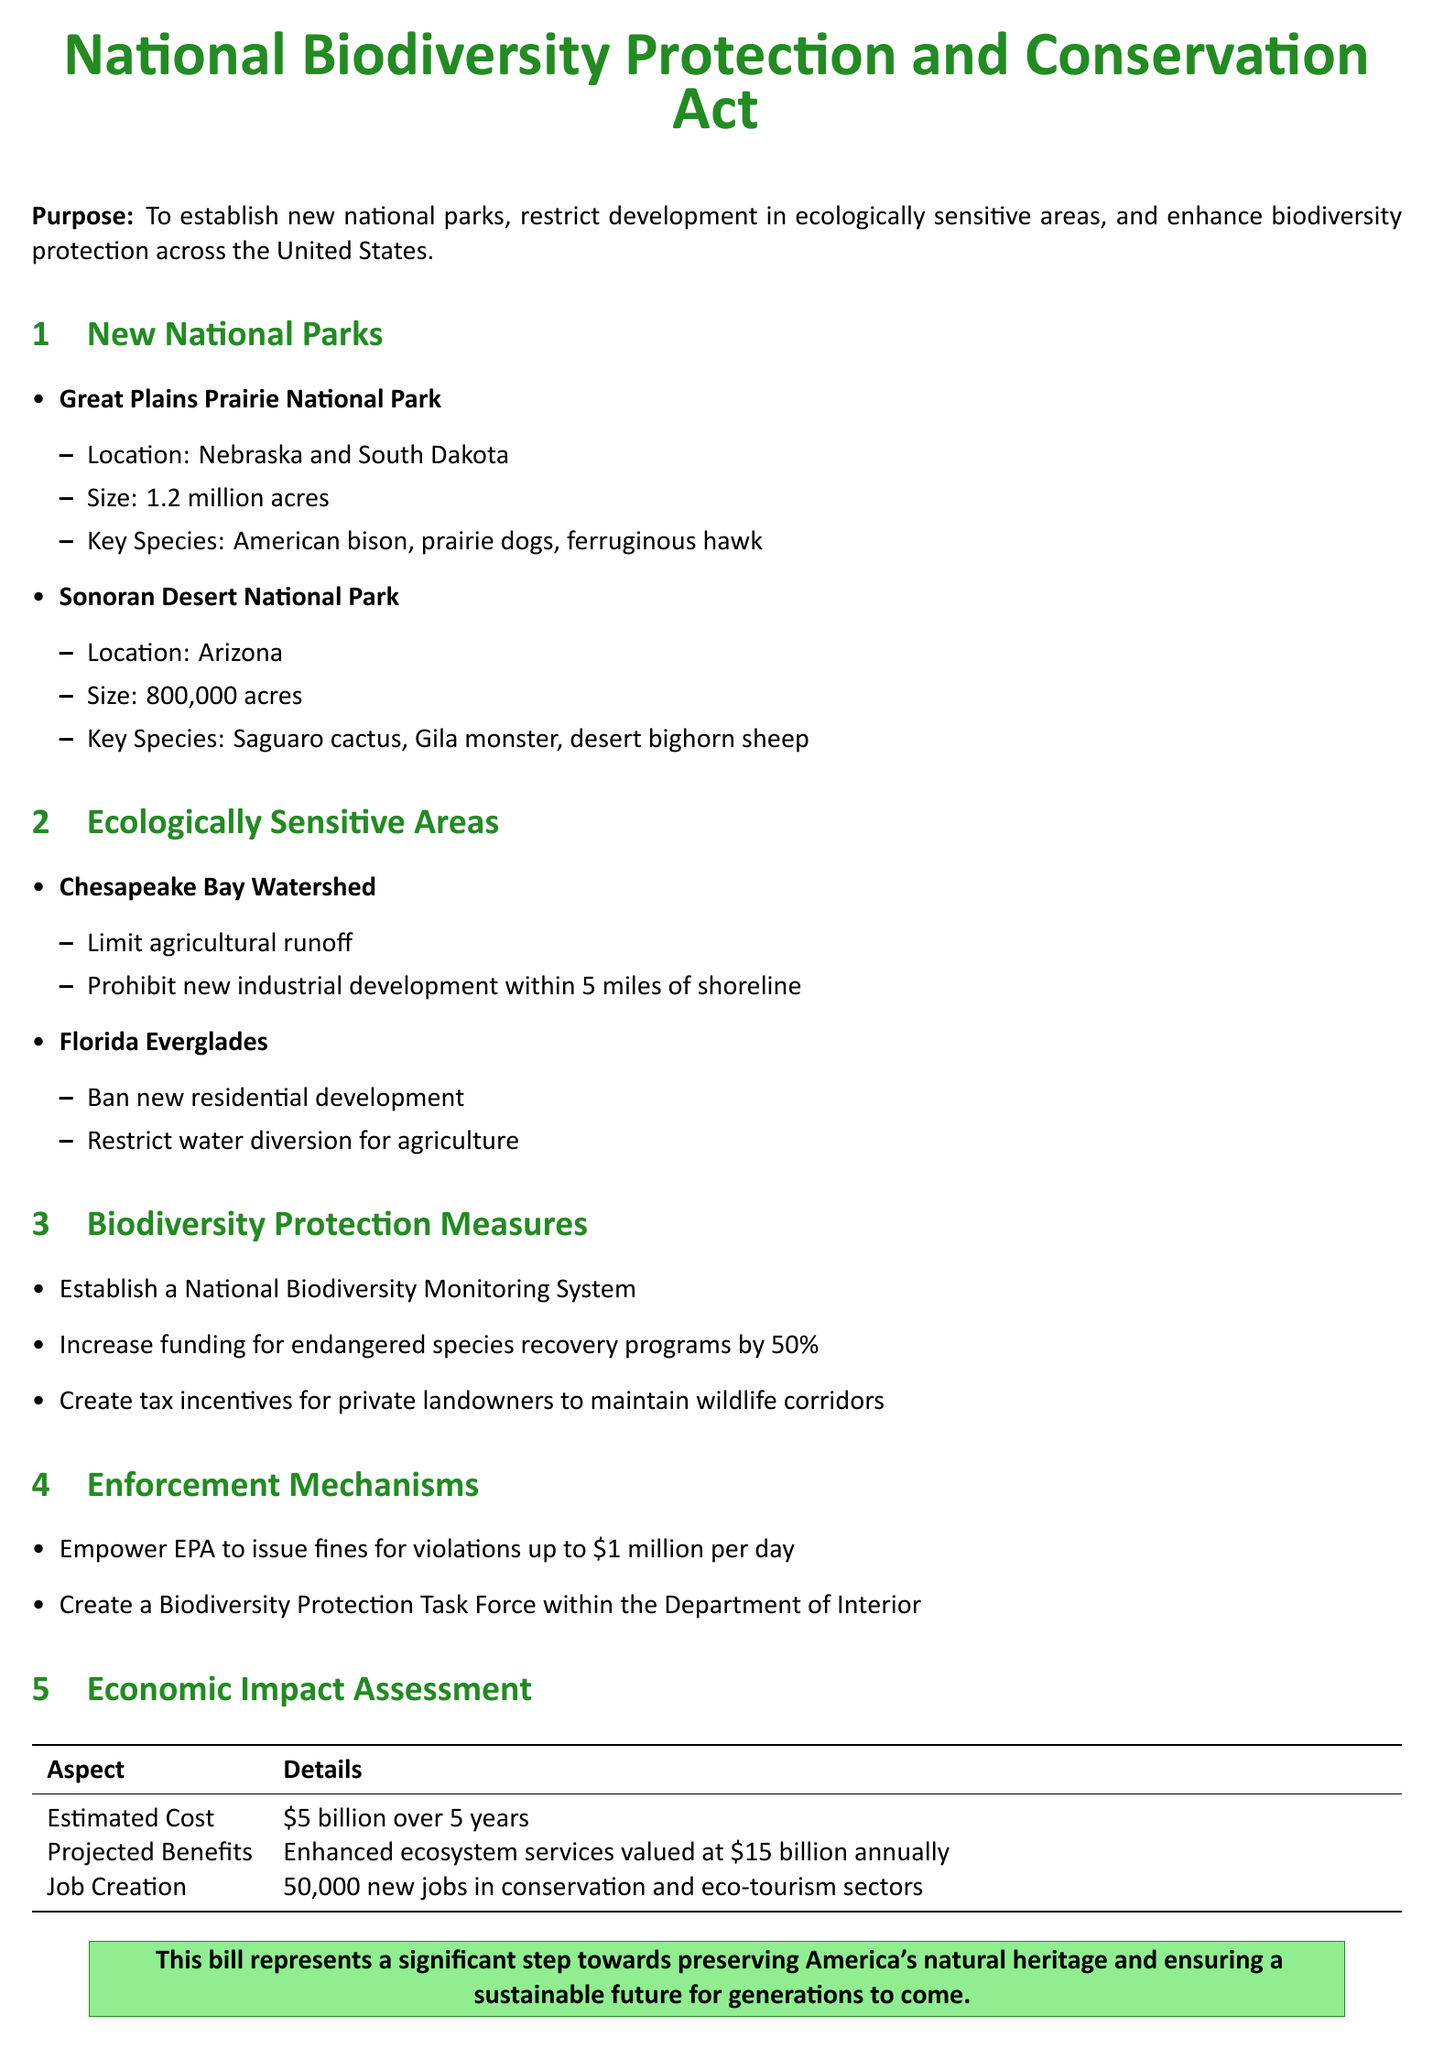What is the purpose of the bill? The purpose is stated in the document to establish new national parks, restrict development in ecologically sensitive areas, and enhance biodiversity protection across the United States.
Answer: To establish new national parks, restrict development, and enhance biodiversity protection What is the size of the Great Plains Prairie National Park? The size is specified in the document as 1.2 million acres.
Answer: 1.2 million acres Which key species is associated with the Sonoran Desert National Park? The document lists key species for this park; one of them is the Saguaro cactus.
Answer: Saguaro cactus What economic impact is projected in terms of job creation? The projected job creation is provided in the economic impact assessment, stating 50,000 new jobs.
Answer: 50,000 What enforcement mechanism is suggested for the violation of this bill? The document mentions the empowerment of the EPA to issue fines for violations as an enforcement mechanism.
Answer: Empower EPA to issue fines How much will funding for endangered species recovery programs increase? The document indicates that funding will increase by 50%.
Answer: 50% What is the estimated cost of implementing the bill? The estimated cost is provided in the economic impact assessment, which states $5 billion over 5 years.
Answer: $5 billion over 5 years What area is highlighted for limiting agricultural runoff? The document specifies the Chesapeake Bay Watershed for limiting agricultural runoff.
Answer: Chesapeake Bay Watershed What is the primary focus of the National Biodiversity Monitoring System? The document does not provide a direct focus, but it indicates this system will be established under biodiversity protection measures.
Answer: Monitoring biodiversity 